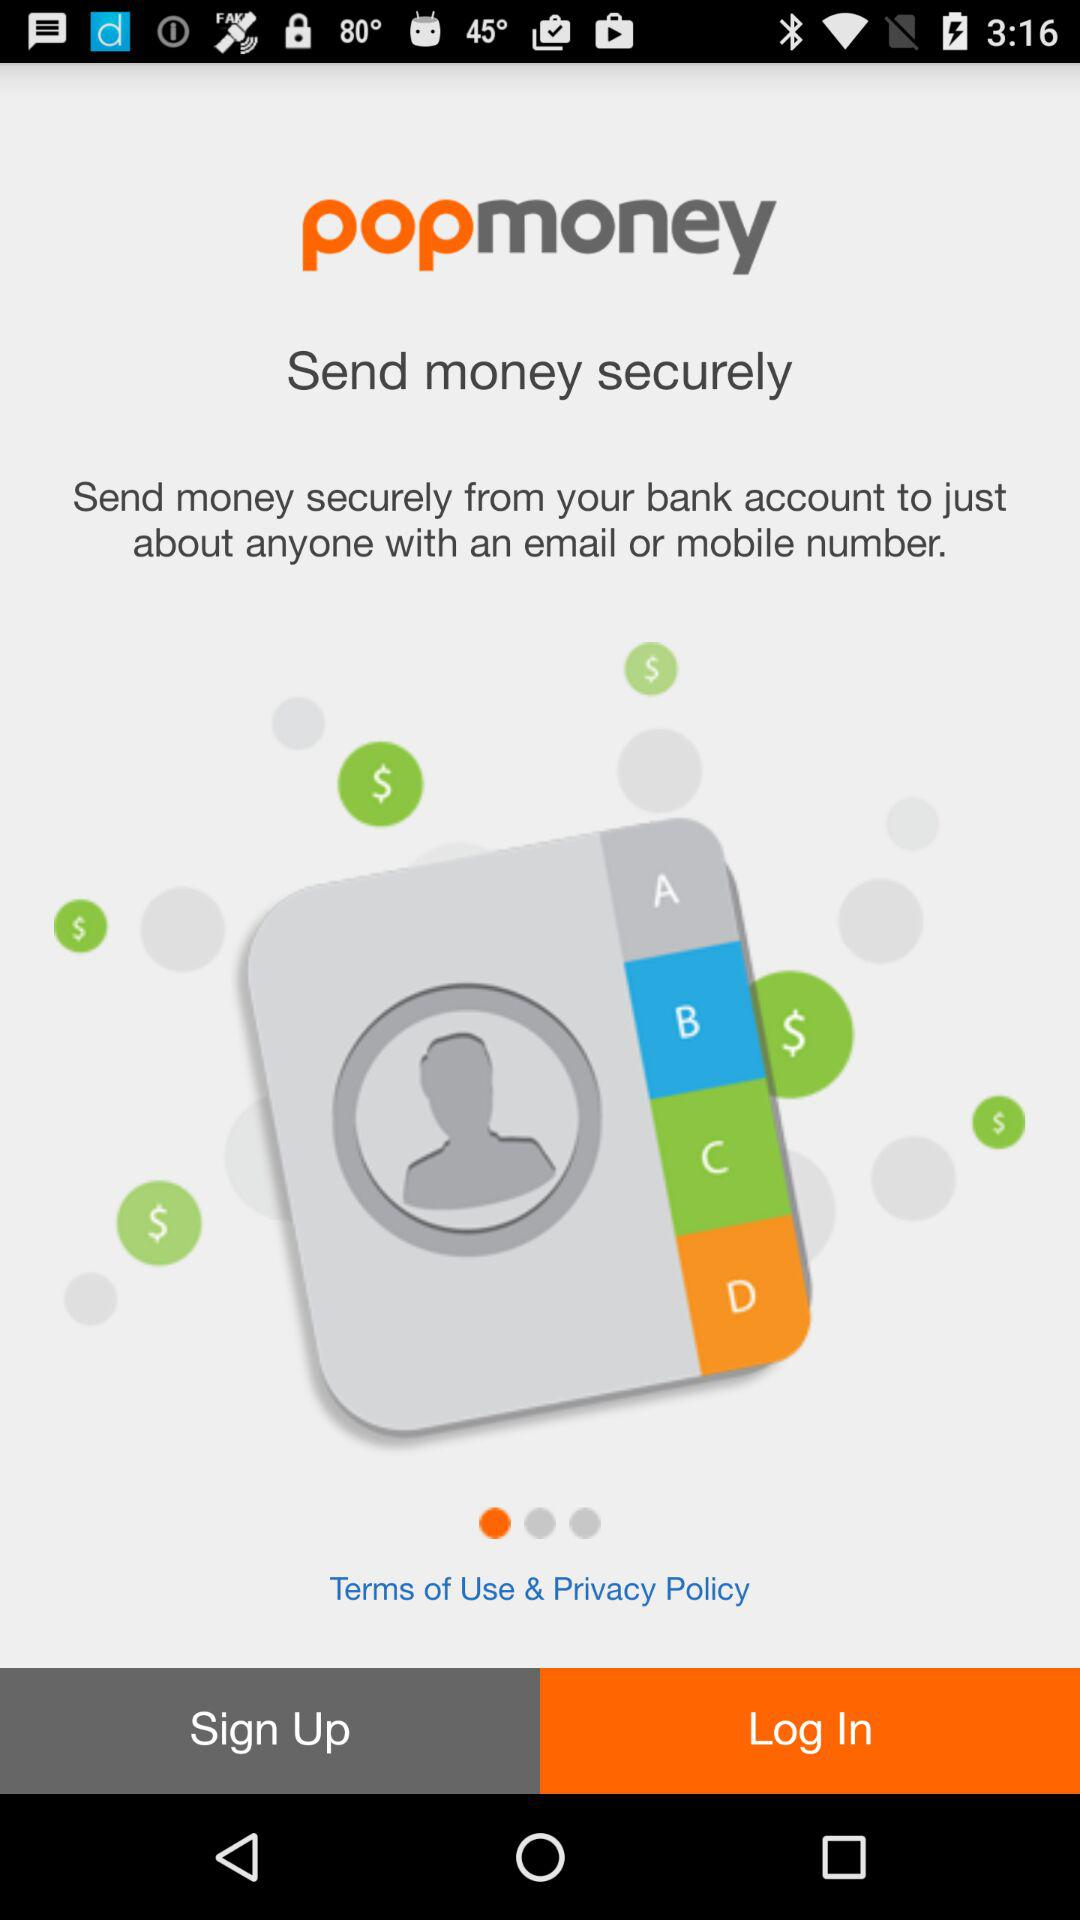What is the application name? The application name is "popmoney". 